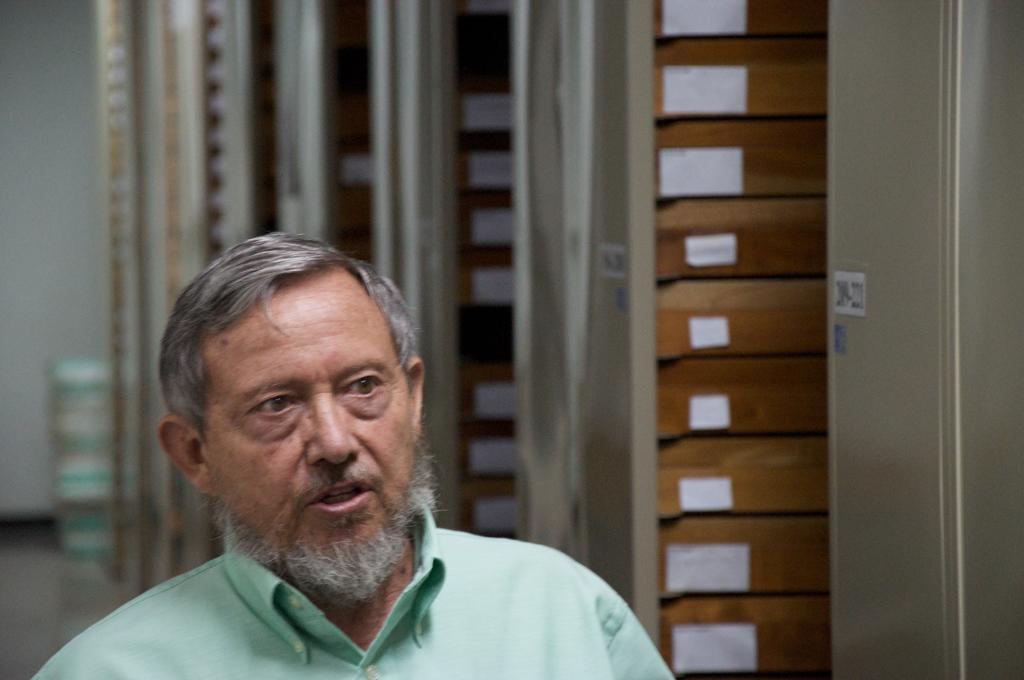Please provide a concise description of this image. In the picture I can see a man. In the background I can see a wall and some other objects. The background of the image is blurred. 